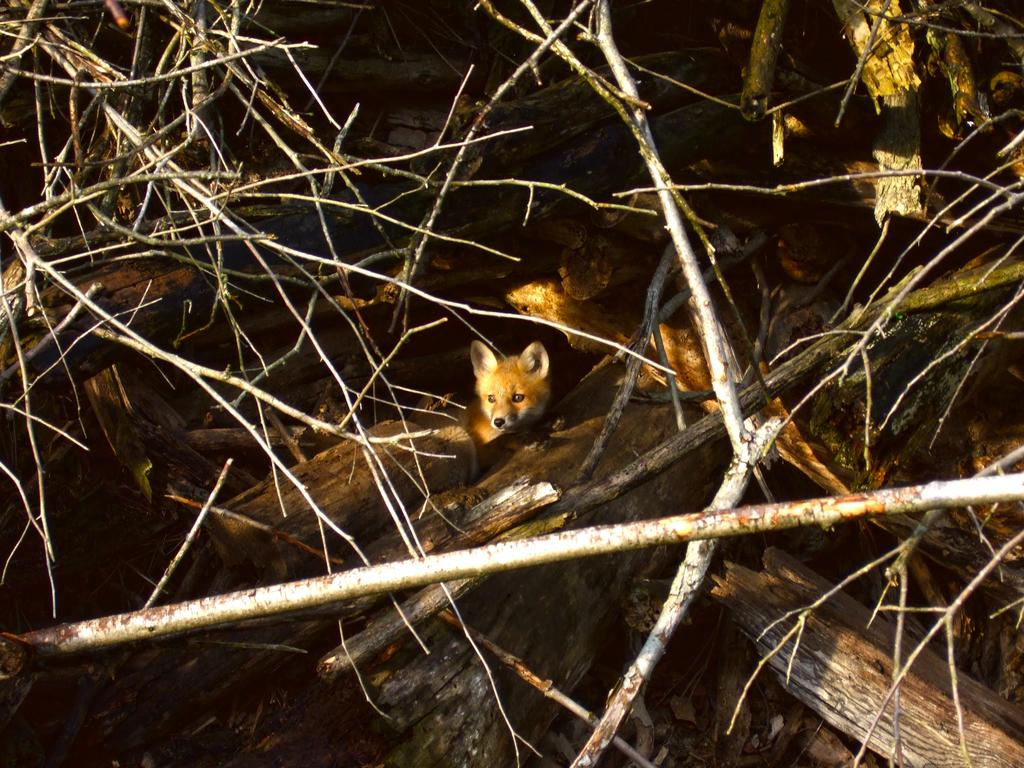What materials are present in the image? There are sticks and wood in the image. What type of living creature can be seen in the image? There is an animal in the image. What type of marble is used to decorate the frame in the image? There is no frame or marble present in the image; it features sticks, wood, and an animal. 